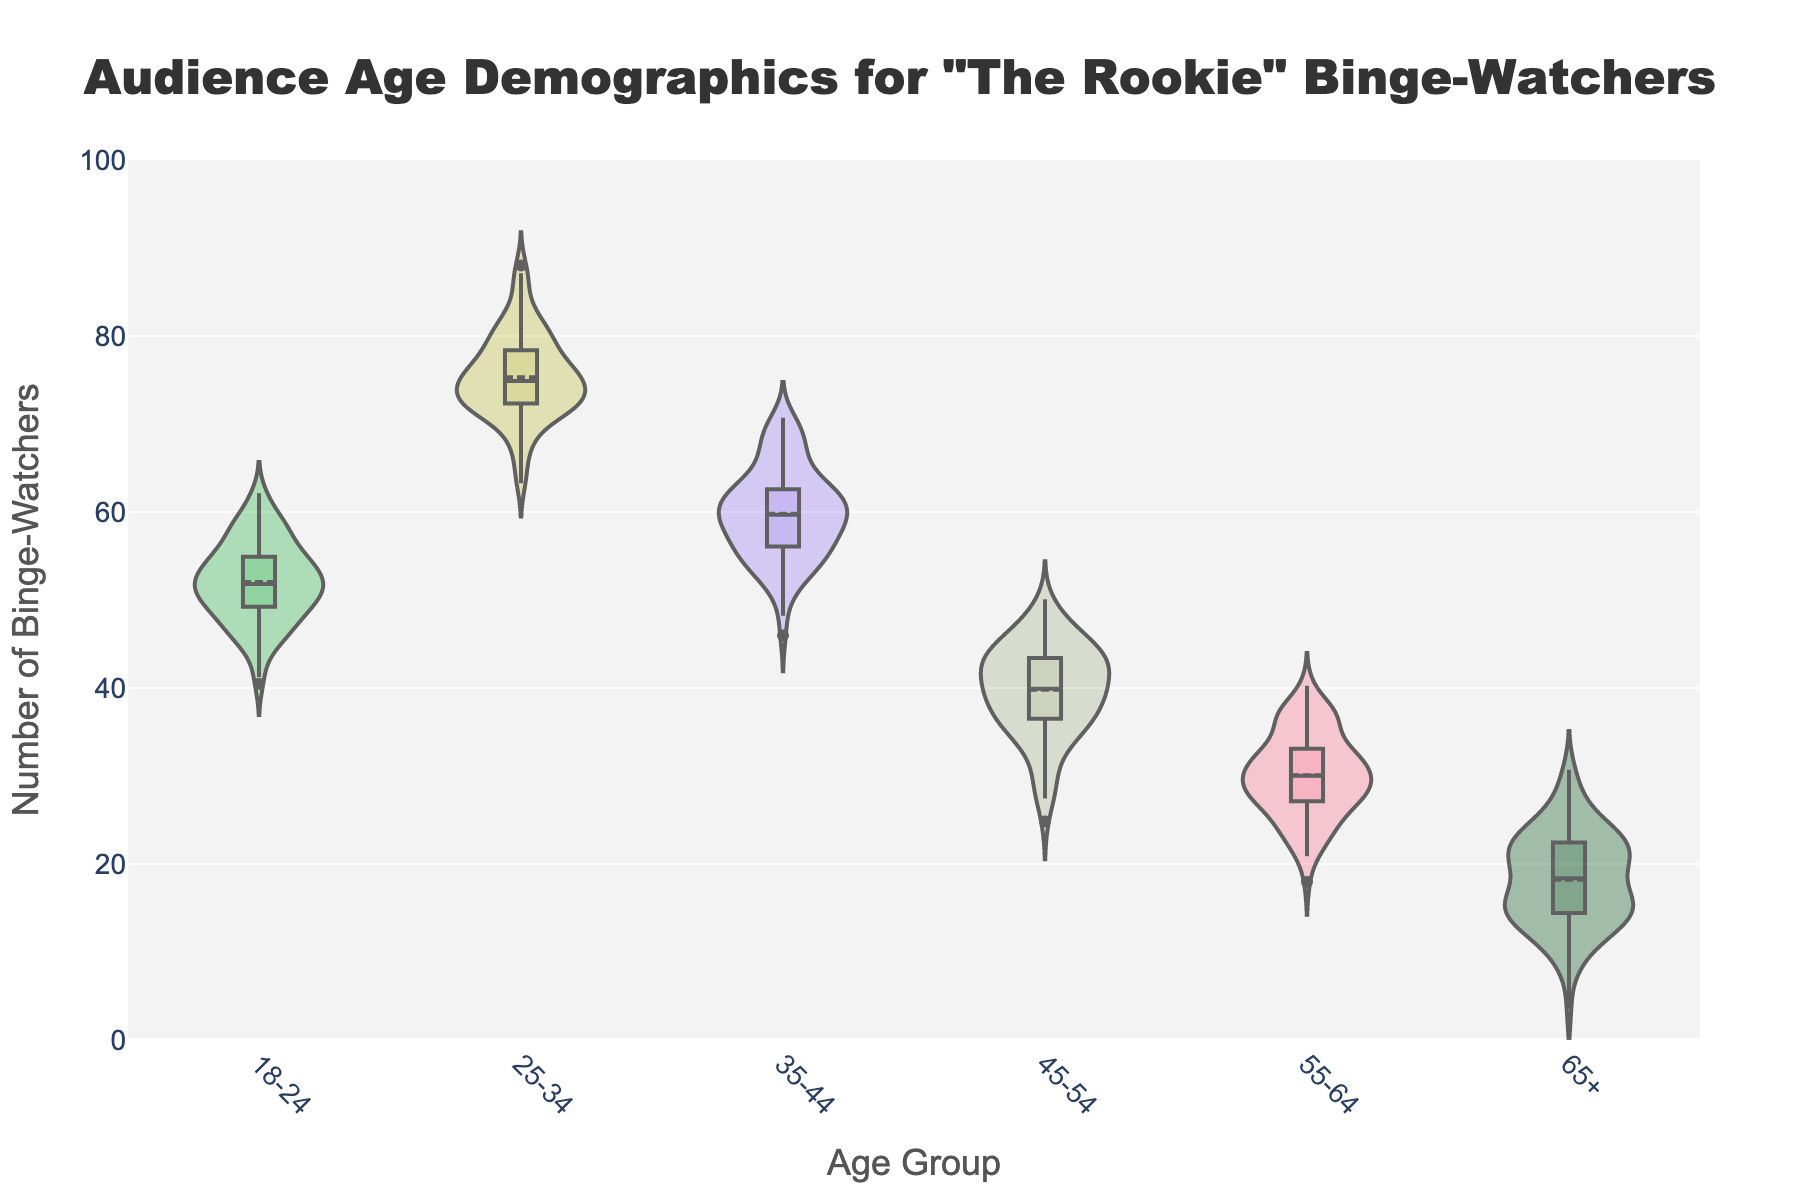What's the title of the chart? The title of the chart is prominently displayed at the top of the figure.
Answer: Audience Age Demographics for "The Rookie" Binge-Watchers What is the y-axis range on this chart? The y-axis is labeled from 0 to 100, as seen by the numeric labels on the y-axis.
Answer: 0 to 100 Which age group has the highest number of binge-watchers? The violin plot with the widest distribution and the highest mean line represents the age group with the highest number. This is the 25-34 age group.
Answer: 25-34 What is the median value for the 18-24 age group? The black line in the center of the box within the violin plot indicates the median value. For the 18-24 age group, it is around 52.
Answer: Around 52 How do the number of binge-watchers in the 35-44 age group compare to the 45-54 age group? The number of binge-watchers in the 35-44 age group is higher than in the 45-54 age group, as indicated by the position and spread of the violin plots.
Answer: Higher Which age group shows the least variation in the number of binge-watchers? The age group with the smallest spread (narrowest violin plot) exhibits the least variation, which appears to be the 55-64 age group.
Answer: 55-64 What's the sum of the number of binge-watchers for the two oldest age groups combined? Add the numbers: 30 (for the 55-64 age group) + 18 (for the 65+ age group) = 48.
Answer: 48 Which age group has a mean number of binge-watchers closest to 60? The mean line (white dot) closest to 60 is found in the 35-44 age group.
Answer: 35-44 Do any age groups exceed 90 binge-watchers? By checking the spread of all violin plots, none exceed a mean value or spread that goes above 90 on the y-axis.
Answer: No 